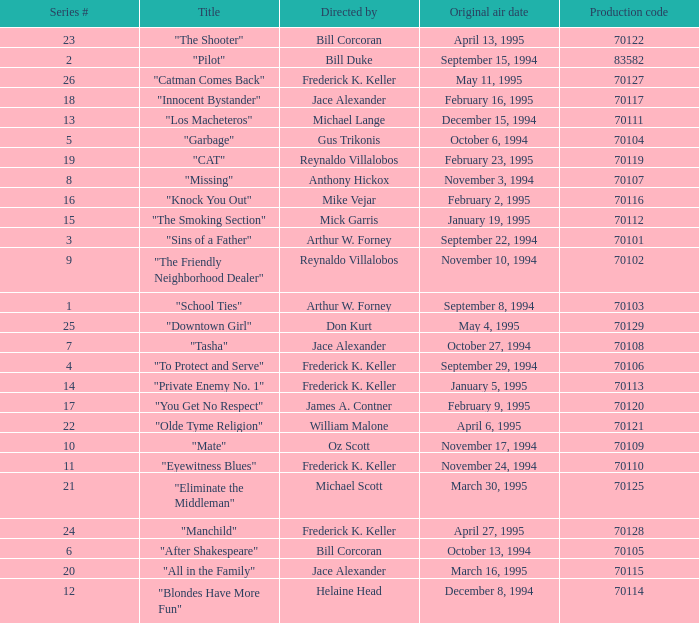For the "Downtown Girl" episode, what was the original air date? May 4, 1995. 